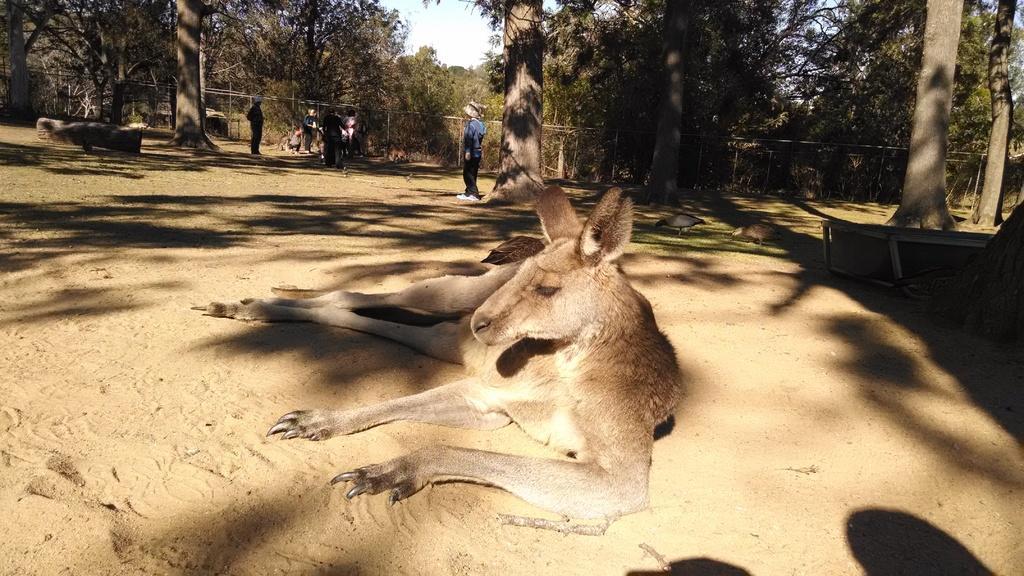Could you give a brief overview of what you see in this image? In this image we can see an animal lying on the sand, birds and persons standing on the sand, name board, benches, wooden fence, trees and sky. 